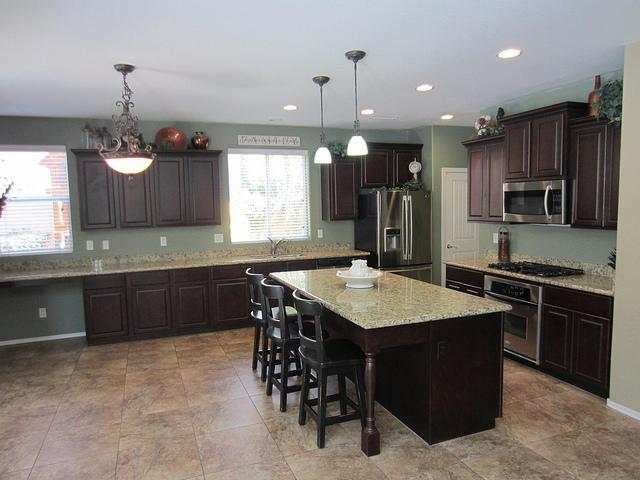How many chairs at the island?
Keep it brief. 3. Is there a TV in the room?
Keep it brief. No. How many pots are there?
Be succinct. 0. How many hanging lights are there?
Give a very brief answer. 3. What room is this?
Concise answer only. Kitchen. Does the floor have a checkered pattern?
Short answer required. No. 